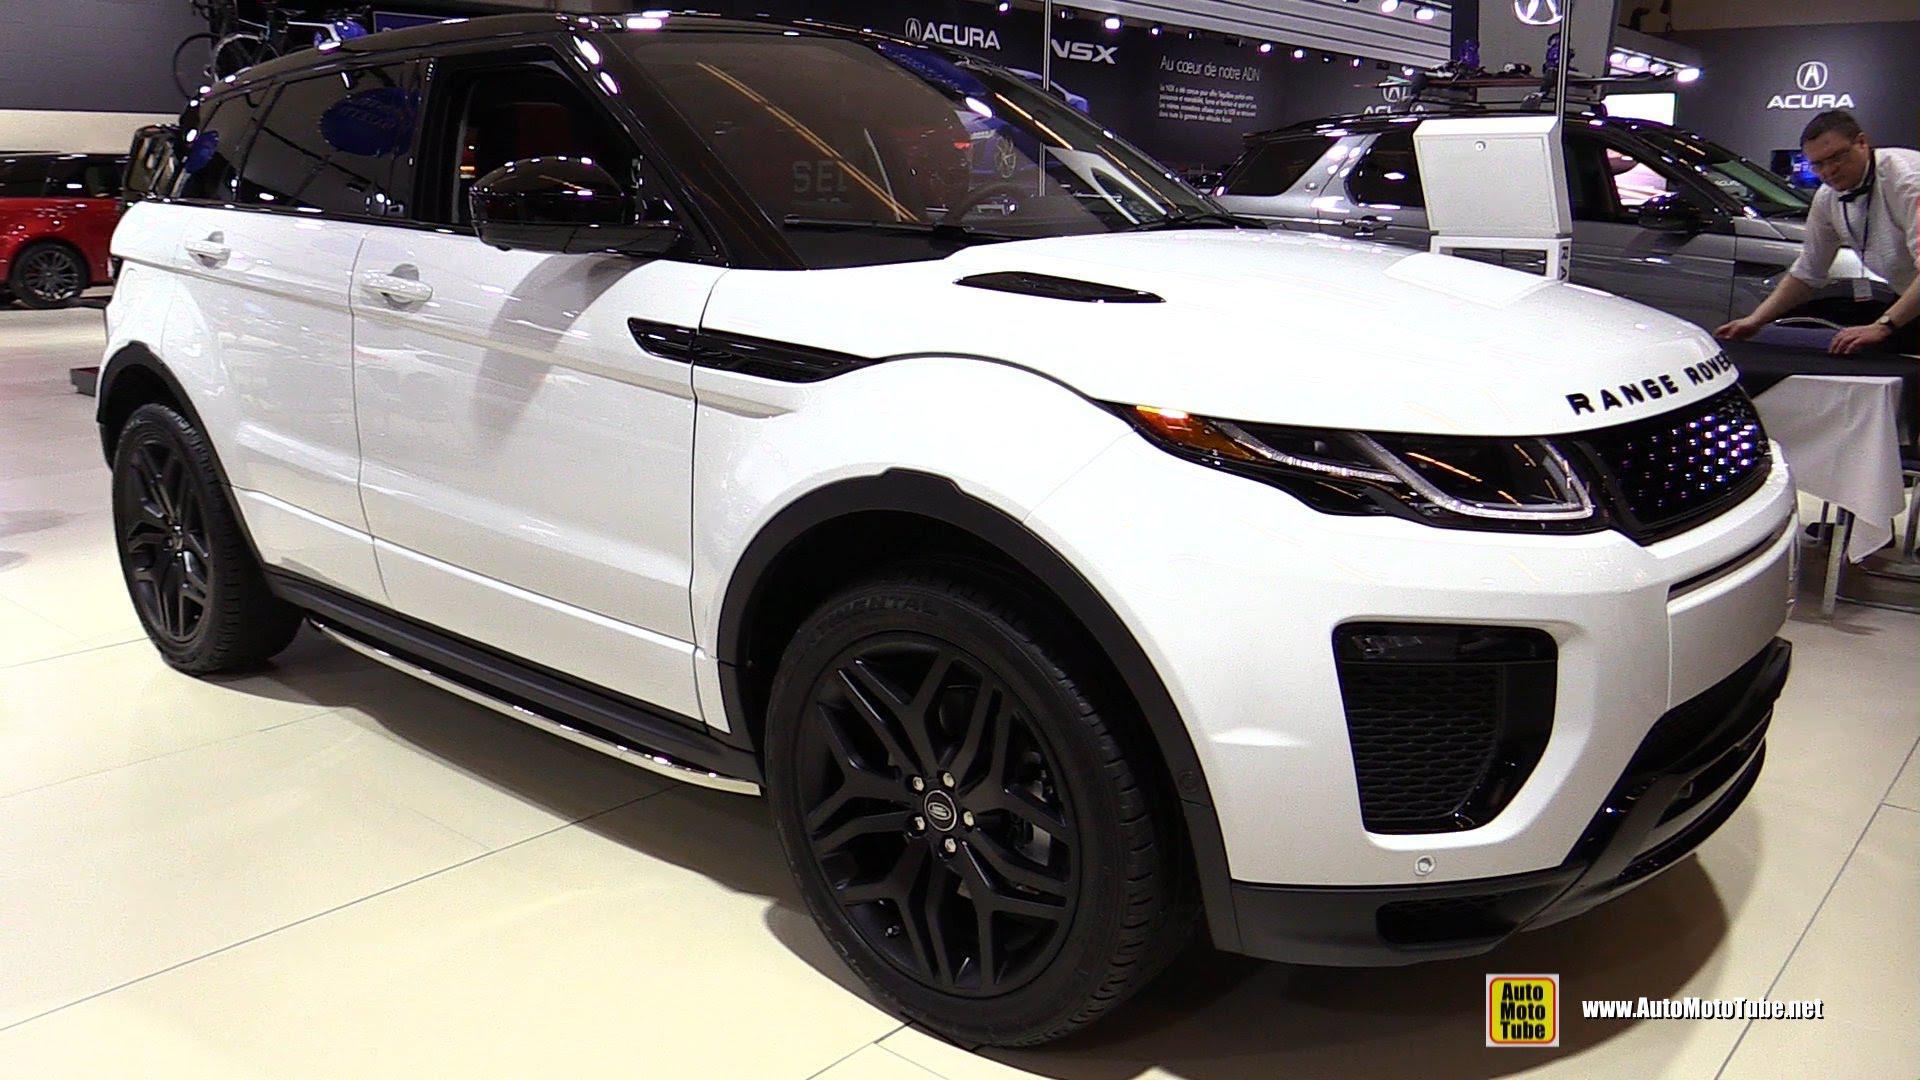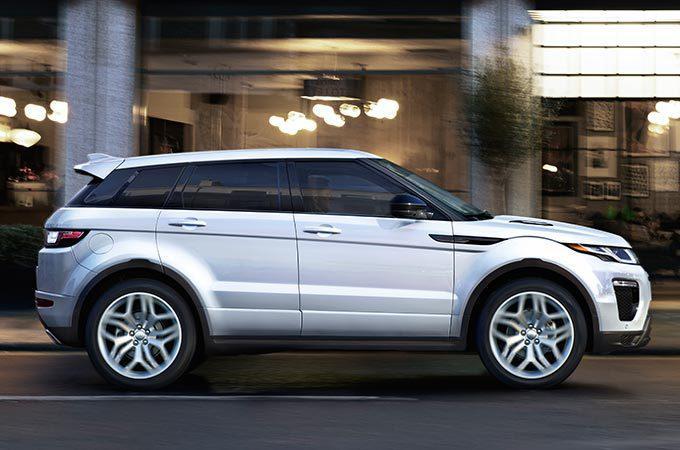The first image is the image on the left, the second image is the image on the right. For the images shown, is this caption "The right image contains a white vehicle that is facing towards the right." true? Answer yes or no. Yes. The first image is the image on the left, the second image is the image on the right. Considering the images on both sides, is "Each image shows a white Range Rover with its top covered, but one car has black rims while the other has silver rims." valid? Answer yes or no. Yes. 